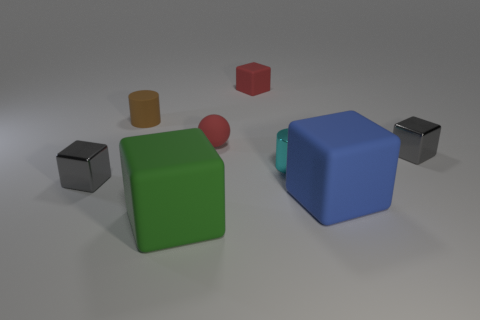There is a brown rubber object; what shape is it?
Offer a very short reply. Cylinder. Are there more small things behind the tiny metallic cylinder than red matte spheres in front of the red rubber ball?
Your answer should be very brief. Yes. Is the color of the tiny metallic block that is on the left side of the red block the same as the big matte thing that is left of the tiny rubber block?
Provide a short and direct response. No. What is the shape of the cyan metallic object that is the same size as the matte ball?
Give a very brief answer. Cylinder. Is there another big green rubber thing that has the same shape as the large green thing?
Offer a terse response. No. Is the tiny red cube behind the green object made of the same material as the gray block that is right of the cyan object?
Provide a succinct answer. No. The small object that is the same color as the tiny ball is what shape?
Offer a very short reply. Cube. What number of large cyan cylinders have the same material as the tiny brown cylinder?
Your answer should be compact. 0. What is the color of the small rubber cylinder?
Provide a succinct answer. Brown. Do the big matte thing that is on the left side of the blue rubber thing and the tiny red thing behind the matte cylinder have the same shape?
Provide a short and direct response. Yes. 